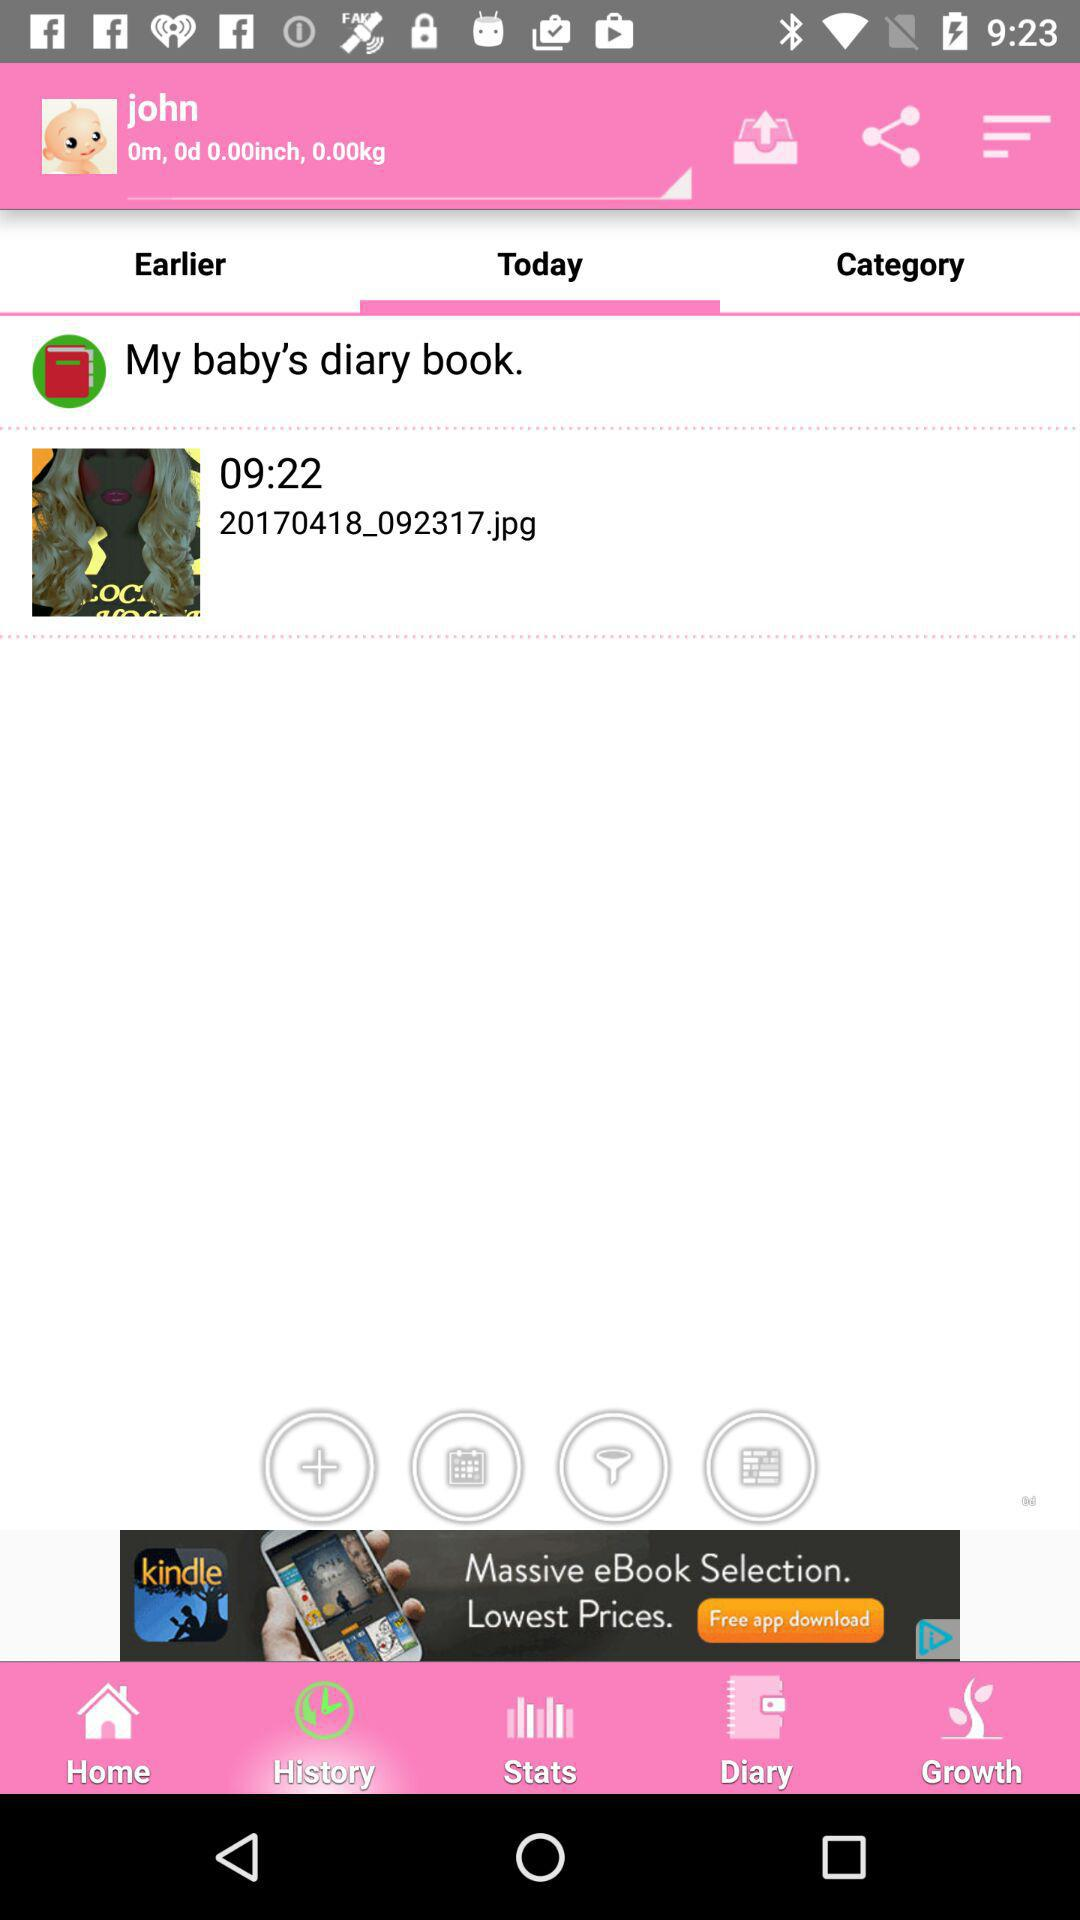What is the name of the baby? The baby name is John. 